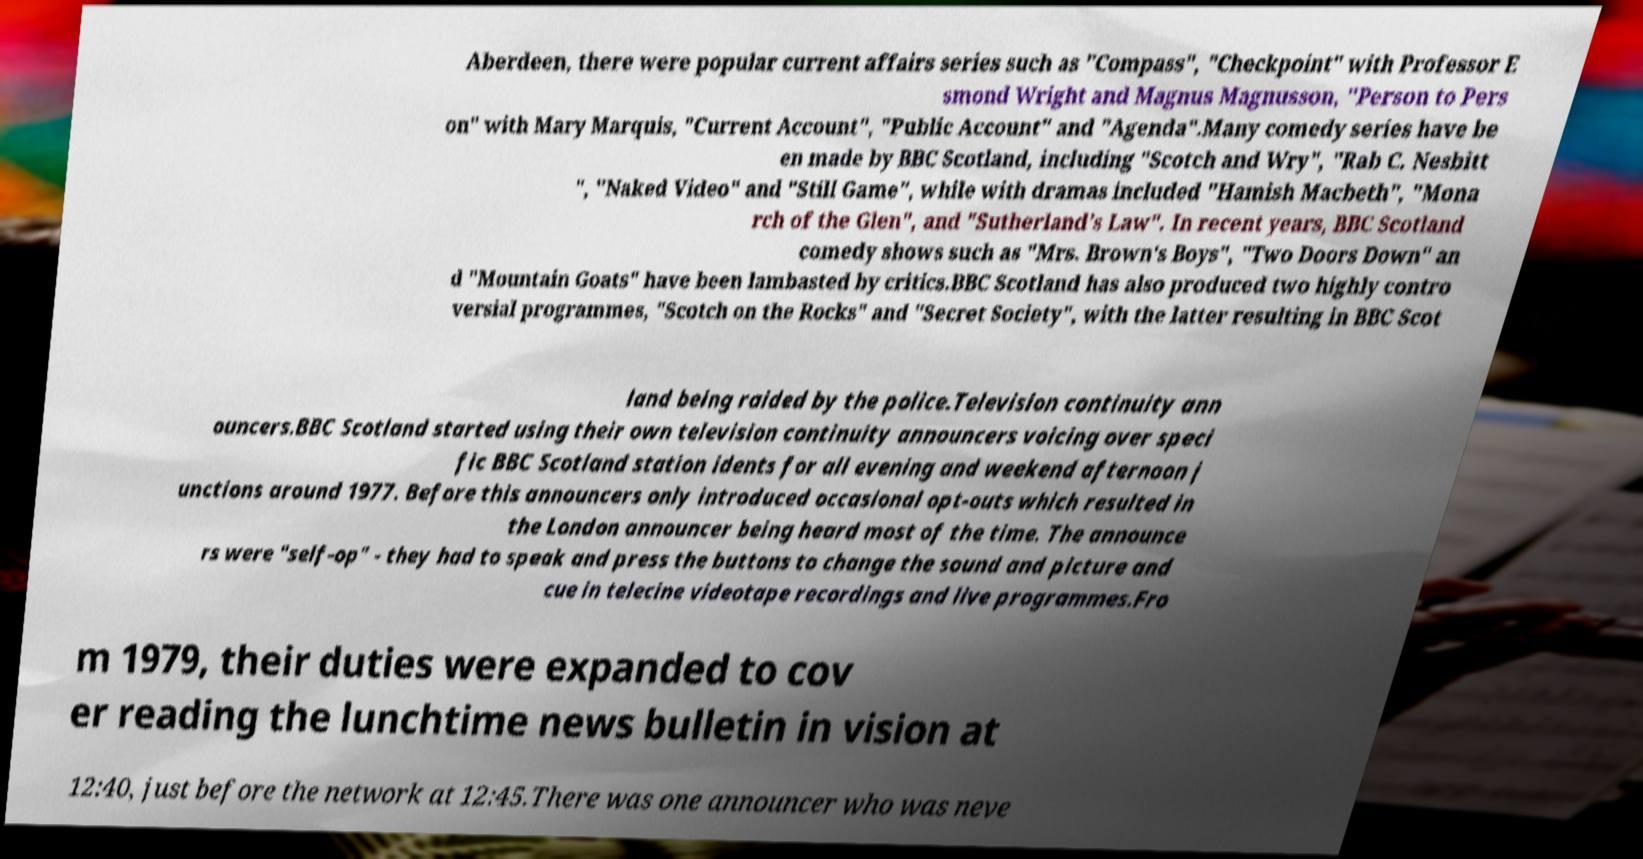For documentation purposes, I need the text within this image transcribed. Could you provide that? Aberdeen, there were popular current affairs series such as "Compass", "Checkpoint" with Professor E smond Wright and Magnus Magnusson, "Person to Pers on" with Mary Marquis, "Current Account", "Public Account" and "Agenda".Many comedy series have be en made by BBC Scotland, including "Scotch and Wry", "Rab C. Nesbitt ", "Naked Video" and "Still Game", while with dramas included "Hamish Macbeth", "Mona rch of the Glen", and "Sutherland's Law". In recent years, BBC Scotland comedy shows such as "Mrs. Brown's Boys", "Two Doors Down" an d "Mountain Goats" have been lambasted by critics.BBC Scotland has also produced two highly contro versial programmes, "Scotch on the Rocks" and "Secret Society", with the latter resulting in BBC Scot land being raided by the police.Television continuity ann ouncers.BBC Scotland started using their own television continuity announcers voicing over speci fic BBC Scotland station idents for all evening and weekend afternoon j unctions around 1977. Before this announcers only introduced occasional opt-outs which resulted in the London announcer being heard most of the time. The announce rs were "self-op" - they had to speak and press the buttons to change the sound and picture and cue in telecine videotape recordings and live programmes.Fro m 1979, their duties were expanded to cov er reading the lunchtime news bulletin in vision at 12:40, just before the network at 12:45.There was one announcer who was neve 